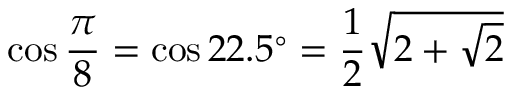<formula> <loc_0><loc_0><loc_500><loc_500>\cos { \frac { \pi } { 8 } } = \cos 2 2 . 5 ^ { \circ } = { \frac { 1 } { 2 } } { \sqrt { 2 + { \sqrt { 2 } } } }</formula> 